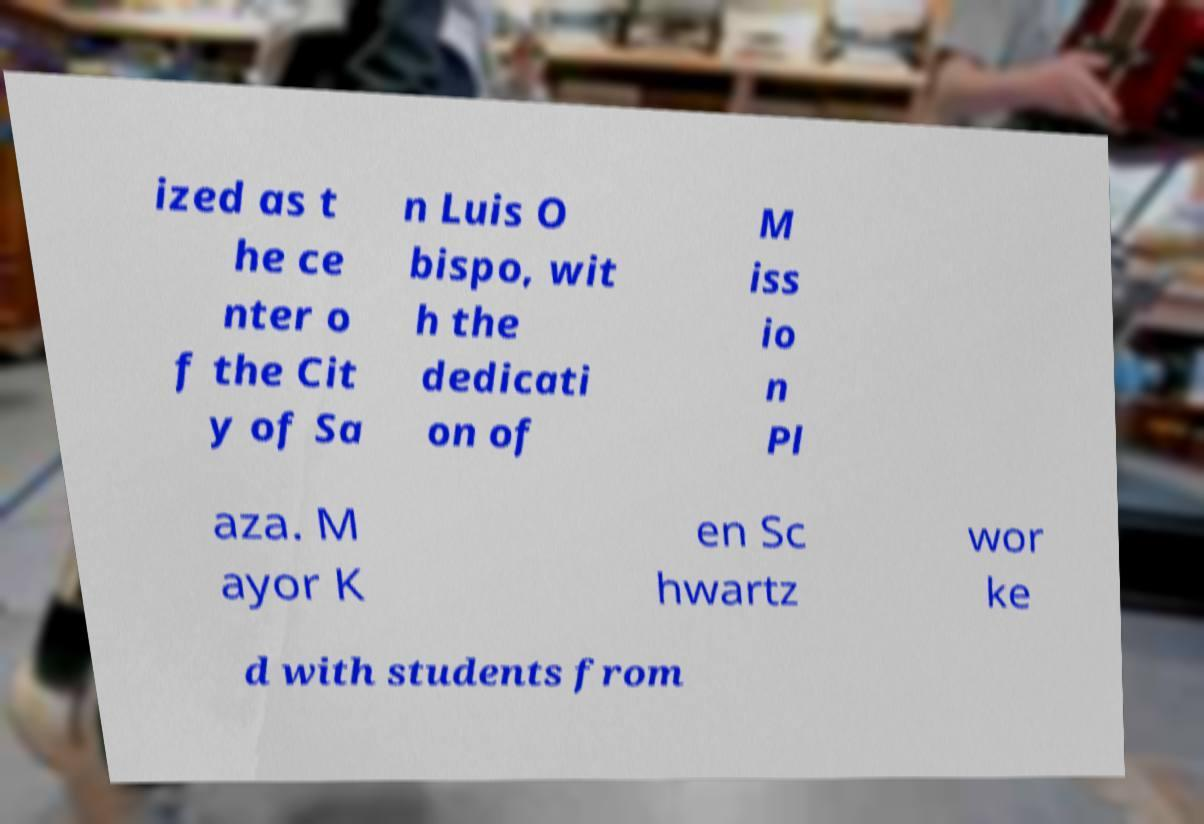Could you extract and type out the text from this image? ized as t he ce nter o f the Cit y of Sa n Luis O bispo, wit h the dedicati on of M iss io n Pl aza. M ayor K en Sc hwartz wor ke d with students from 